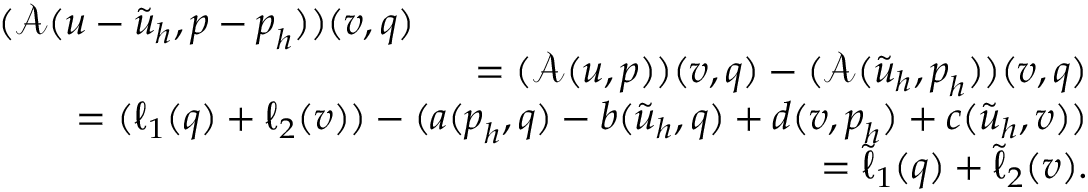<formula> <loc_0><loc_0><loc_500><loc_500>\begin{array} { r l r } { { ( \mathcal { A } ( u - \tilde { u } _ { h } , p - p _ { h } ) ) ( v , q ) } } \\ & { = ( \mathcal { A } ( u , p ) ) ( v , q ) - ( \mathcal { A } ( \tilde { u } _ { h } , p _ { h } ) ) ( v , q ) } \\ & { = ( \ell _ { 1 } ( q ) + \ell _ { 2 } ( v ) ) - ( a ( p _ { h } , q ) - b ( \tilde { u } _ { h } , q ) + d ( v , p _ { h } ) + c ( \tilde { u } _ { h } , v ) ) } \\ & { = \tilde { \ell } _ { 1 } ( q ) + \tilde { \ell } _ { 2 } ( v ) . } \end{array}</formula> 